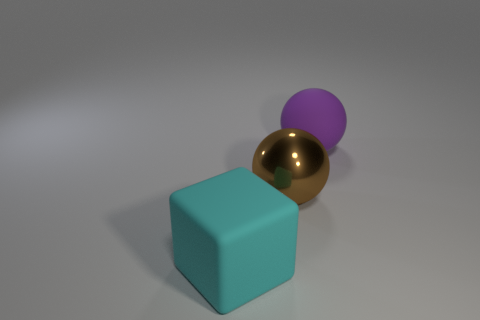Are there any other things that have the same material as the brown ball?
Give a very brief answer. No. What is the cyan cube made of?
Your answer should be very brief. Rubber. Is the material of the cyan cube the same as the thing that is right of the large metallic ball?
Give a very brief answer. Yes. Are there fewer big brown things that are on the left side of the large matte cube than rubber objects on the left side of the large purple matte ball?
Offer a very short reply. Yes. What color is the big object on the left side of the big metallic thing?
Offer a very short reply. Cyan. What number of other objects are there of the same color as the cube?
Offer a very short reply. 0. There is a purple rubber thing; what number of rubber spheres are behind it?
Make the answer very short. 0. Is there another thing of the same size as the metal thing?
Provide a short and direct response. Yes. Do the big rubber block and the rubber sphere have the same color?
Offer a terse response. No. There is a large ball that is to the left of the rubber thing right of the large cyan matte block; what is its color?
Give a very brief answer. Brown. 